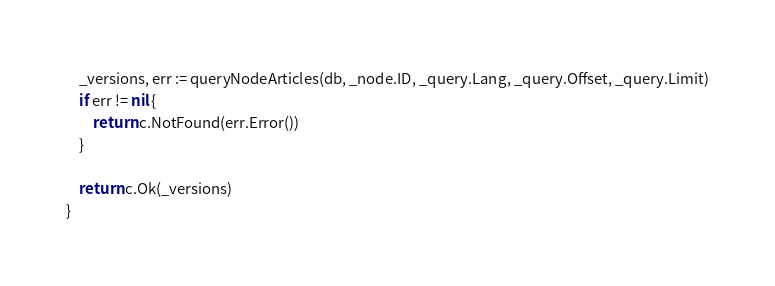<code> <loc_0><loc_0><loc_500><loc_500><_Go_>	_versions, err := queryNodeArticles(db, _node.ID, _query.Lang, _query.Offset, _query.Limit)
	if err != nil {
		return c.NotFound(err.Error())
	}

	return c.Ok(_versions)
}
</code> 